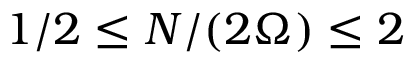Convert formula to latex. <formula><loc_0><loc_0><loc_500><loc_500>1 / 2 \leq N / ( 2 \Omega ) \leq 2</formula> 